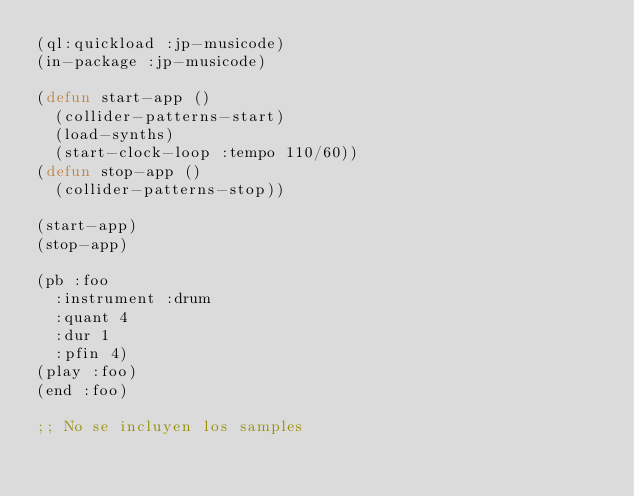Convert code to text. <code><loc_0><loc_0><loc_500><loc_500><_Lisp_>(ql:quickload :jp-musicode)
(in-package :jp-musicode)

(defun start-app ()
  (collider-patterns-start)
  (load-synths)
  (start-clock-loop :tempo 110/60))
(defun stop-app ()
  (collider-patterns-stop))

(start-app)
(stop-app)

(pb :foo
  :instrument :drum
  :quant 4
  :dur 1
  :pfin 4)
(play :foo)
(end :foo)

;; No se incluyen los samples</code> 